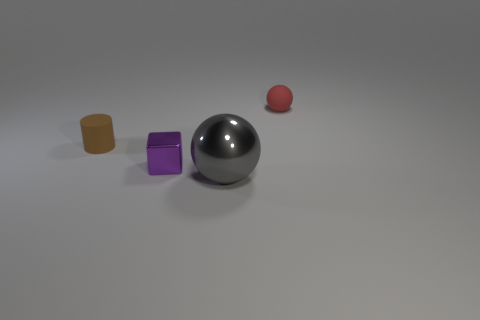Add 2 gray balls. How many objects exist? 6 Subtract all cubes. How many objects are left? 3 Add 2 large gray metallic things. How many large gray metallic things are left? 3 Add 2 big purple metal things. How many big purple metal things exist? 2 Subtract 0 purple spheres. How many objects are left? 4 Subtract all tiny red spheres. Subtract all green shiny cylinders. How many objects are left? 3 